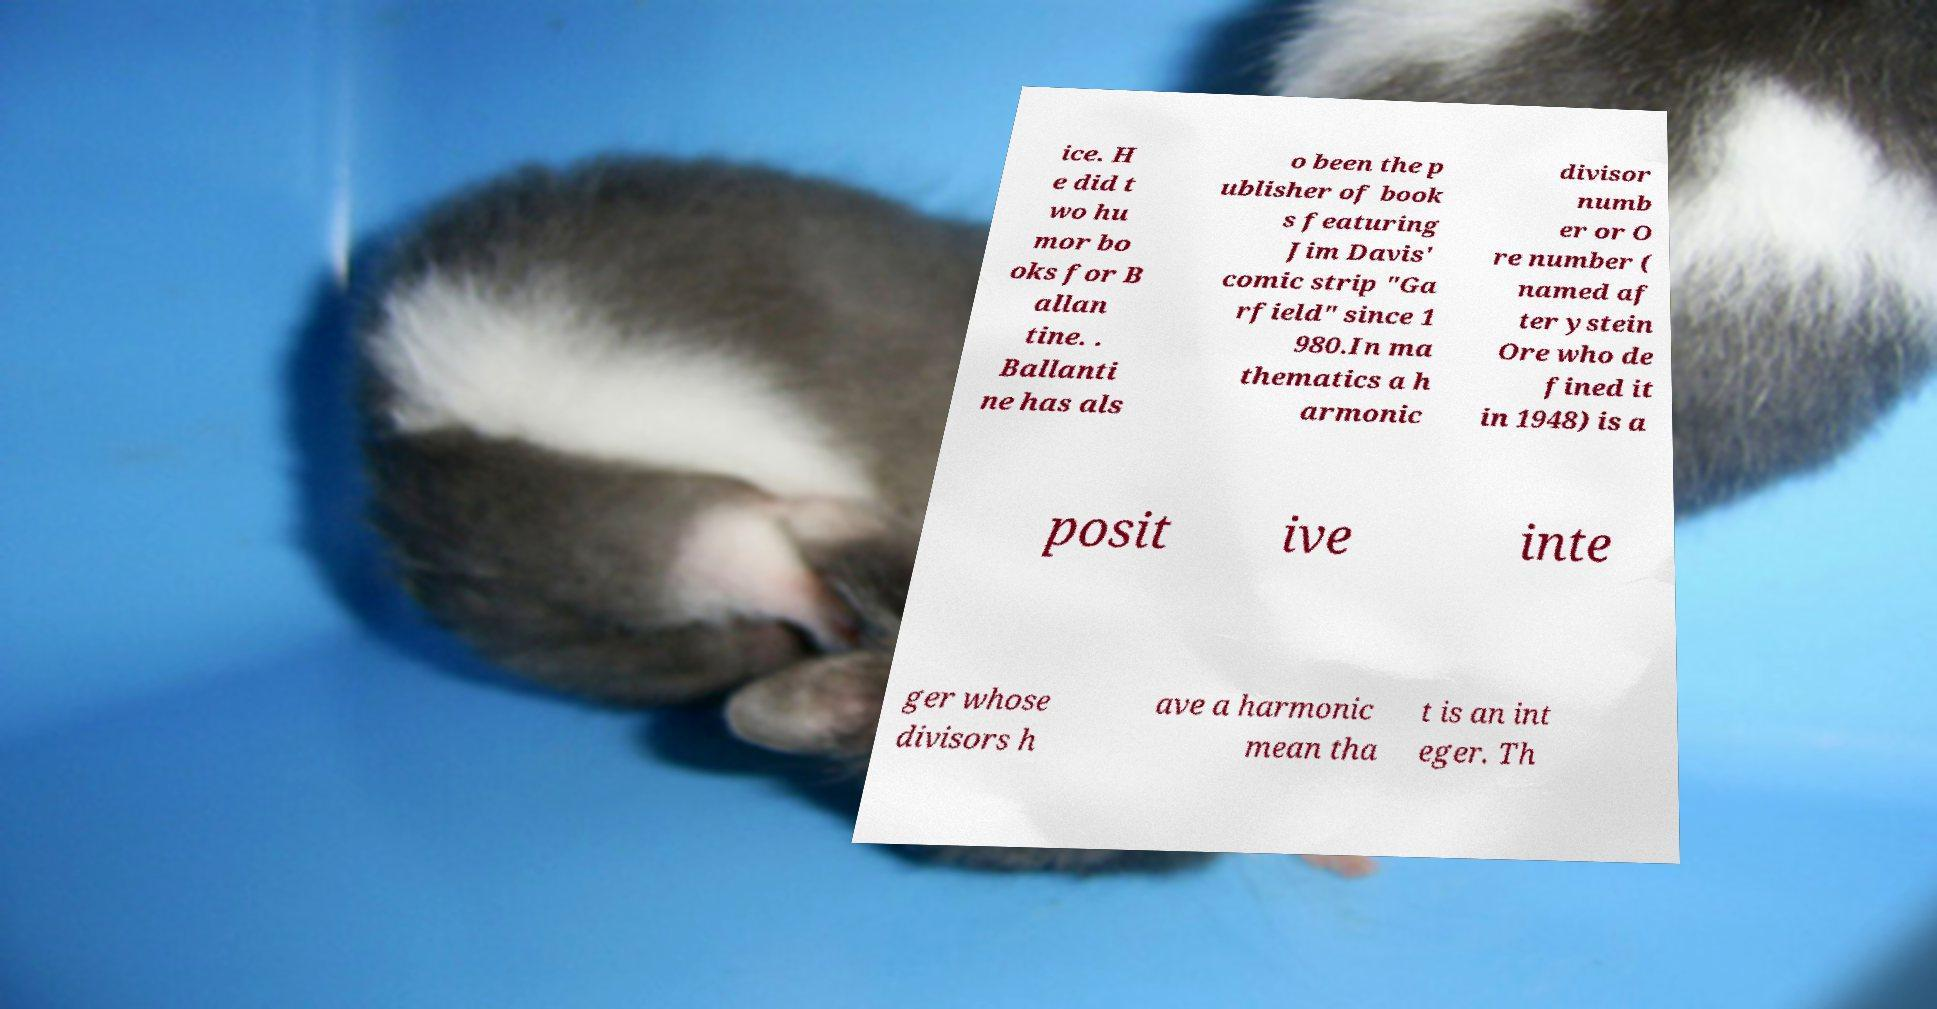Can you accurately transcribe the text from the provided image for me? ice. H e did t wo hu mor bo oks for B allan tine. . Ballanti ne has als o been the p ublisher of book s featuring Jim Davis' comic strip "Ga rfield" since 1 980.In ma thematics a h armonic divisor numb er or O re number ( named af ter ystein Ore who de fined it in 1948) is a posit ive inte ger whose divisors h ave a harmonic mean tha t is an int eger. Th 